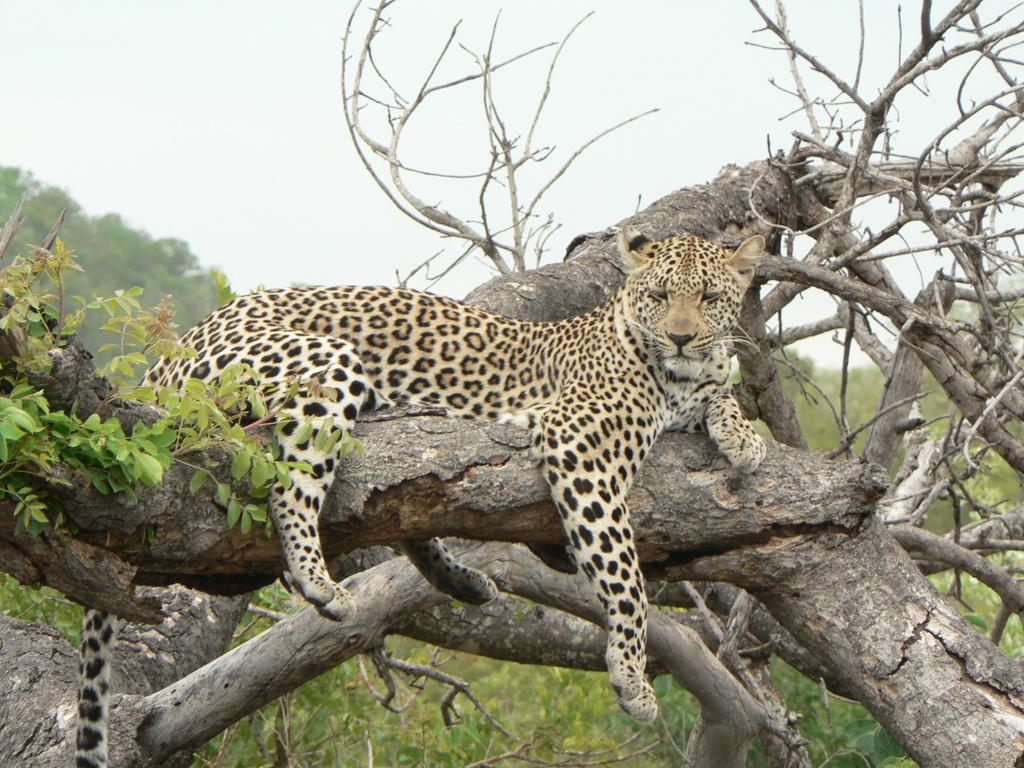What type of animal is in the image? There is a brown color leopard in the image. What is the leopard doing in the image? The leopard is sitting on a tree branch. What can be seen in the background of the image? There are trees visible in the background of the image. What type of lace is the leopard using to climb the tree in the image? There is no lace present in the image, and the leopard is sitting on the tree branch, not climbing it. 